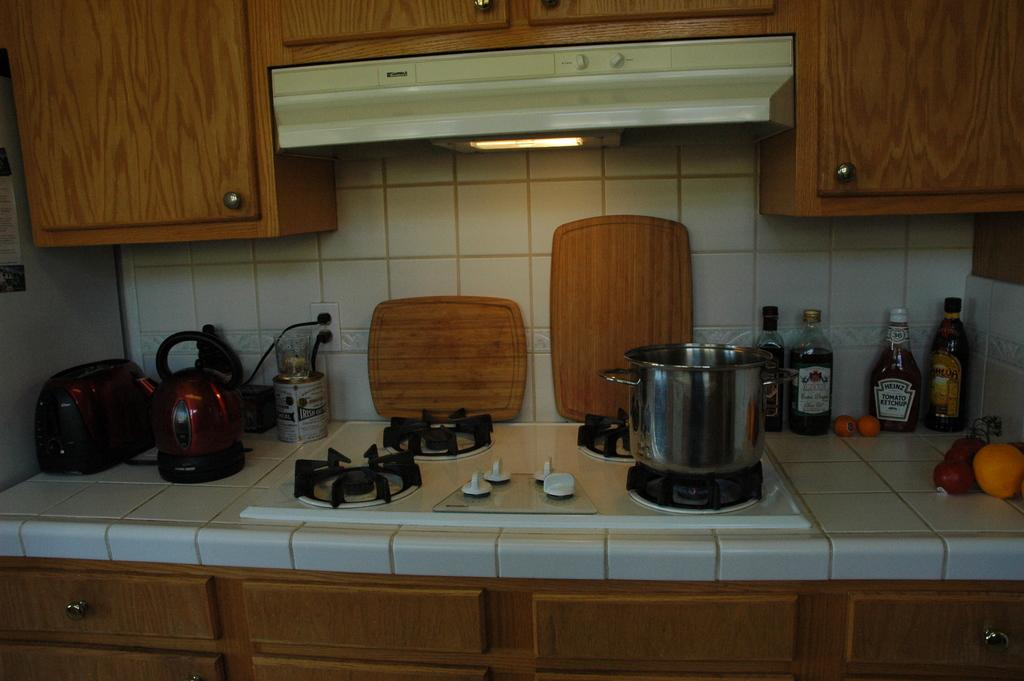<image>
Give a short and clear explanation of the subsequent image. a pot is on the stove and some bottles such as heinz ketchup are on the side of the pot. 